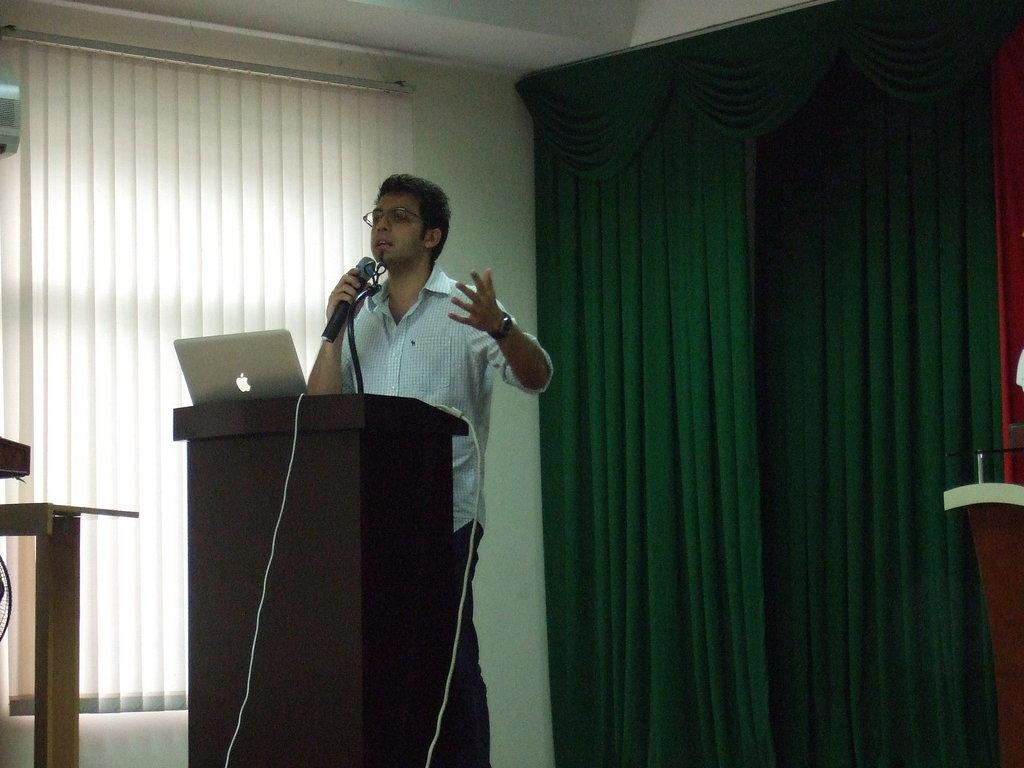What is the person in the image doing? The person in the image is talking. What object is the person holding while talking? The person is holding a microphone. What is in front of the person while they are talking? There is a podium in front of the person. What electronic device is present in the image? There is a laptop in the image. Are there any other microphones visible in the image? Yes, there is another microphone in the image. What type of background can be seen in the image? There are curtains and a wall visible in the image. What type of stitch is being used to hold the curtains together in the image? There is no stitch visible in the image, as the curtains are not being held together. 